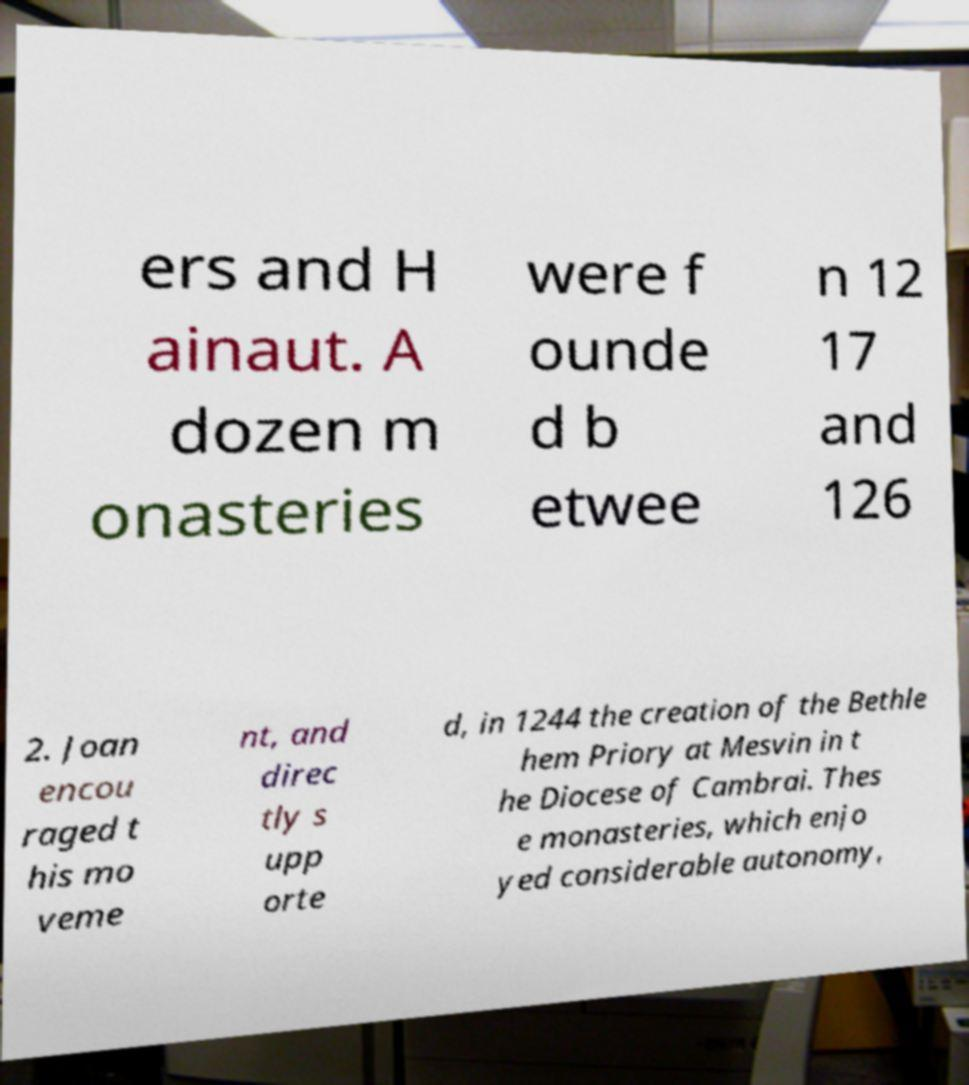I need the written content from this picture converted into text. Can you do that? ers and H ainaut. A dozen m onasteries were f ounde d b etwee n 12 17 and 126 2. Joan encou raged t his mo veme nt, and direc tly s upp orte d, in 1244 the creation of the Bethle hem Priory at Mesvin in t he Diocese of Cambrai. Thes e monasteries, which enjo yed considerable autonomy, 